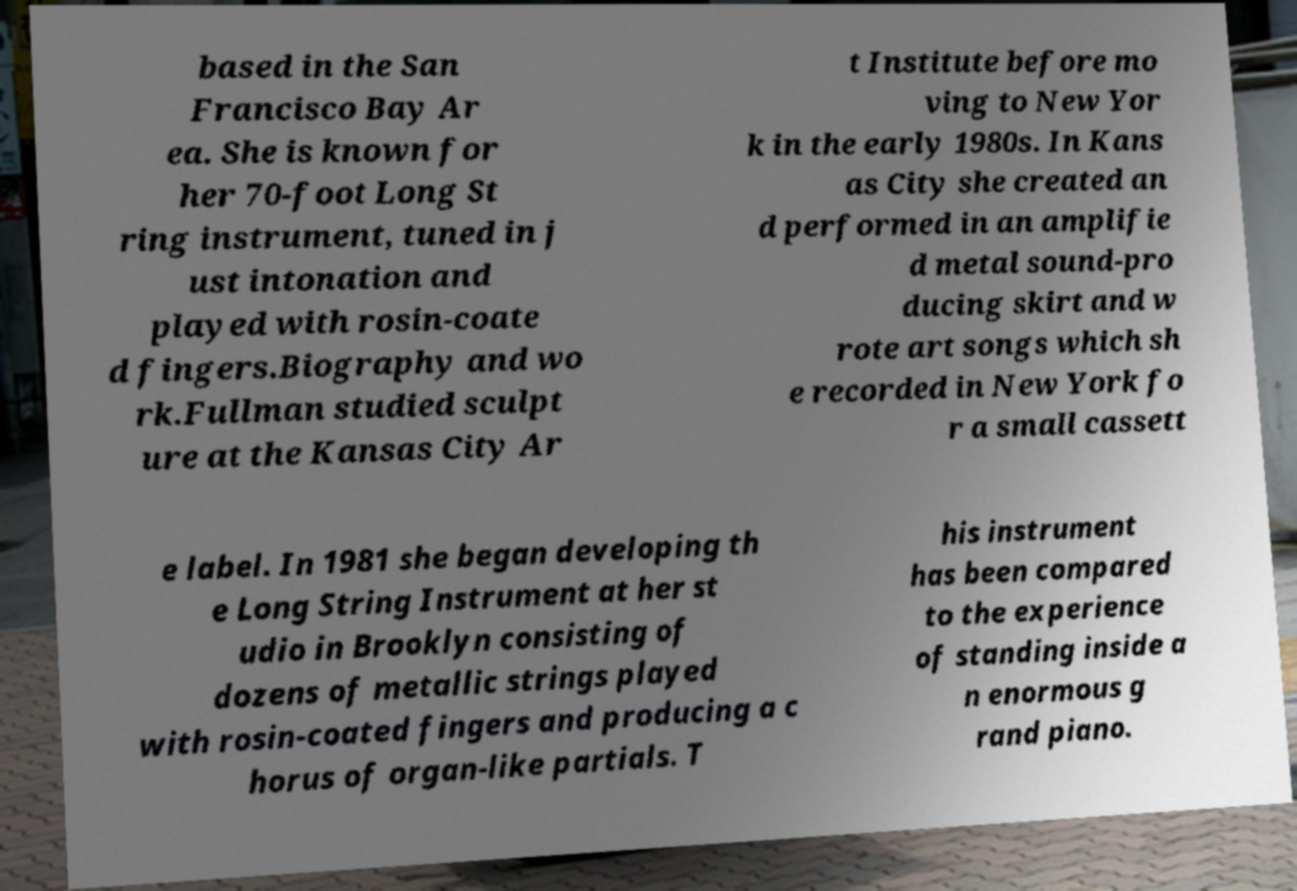There's text embedded in this image that I need extracted. Can you transcribe it verbatim? based in the San Francisco Bay Ar ea. She is known for her 70-foot Long St ring instrument, tuned in j ust intonation and played with rosin-coate d fingers.Biography and wo rk.Fullman studied sculpt ure at the Kansas City Ar t Institute before mo ving to New Yor k in the early 1980s. In Kans as City she created an d performed in an amplifie d metal sound-pro ducing skirt and w rote art songs which sh e recorded in New York fo r a small cassett e label. In 1981 she began developing th e Long String Instrument at her st udio in Brooklyn consisting of dozens of metallic strings played with rosin-coated fingers and producing a c horus of organ-like partials. T his instrument has been compared to the experience of standing inside a n enormous g rand piano. 